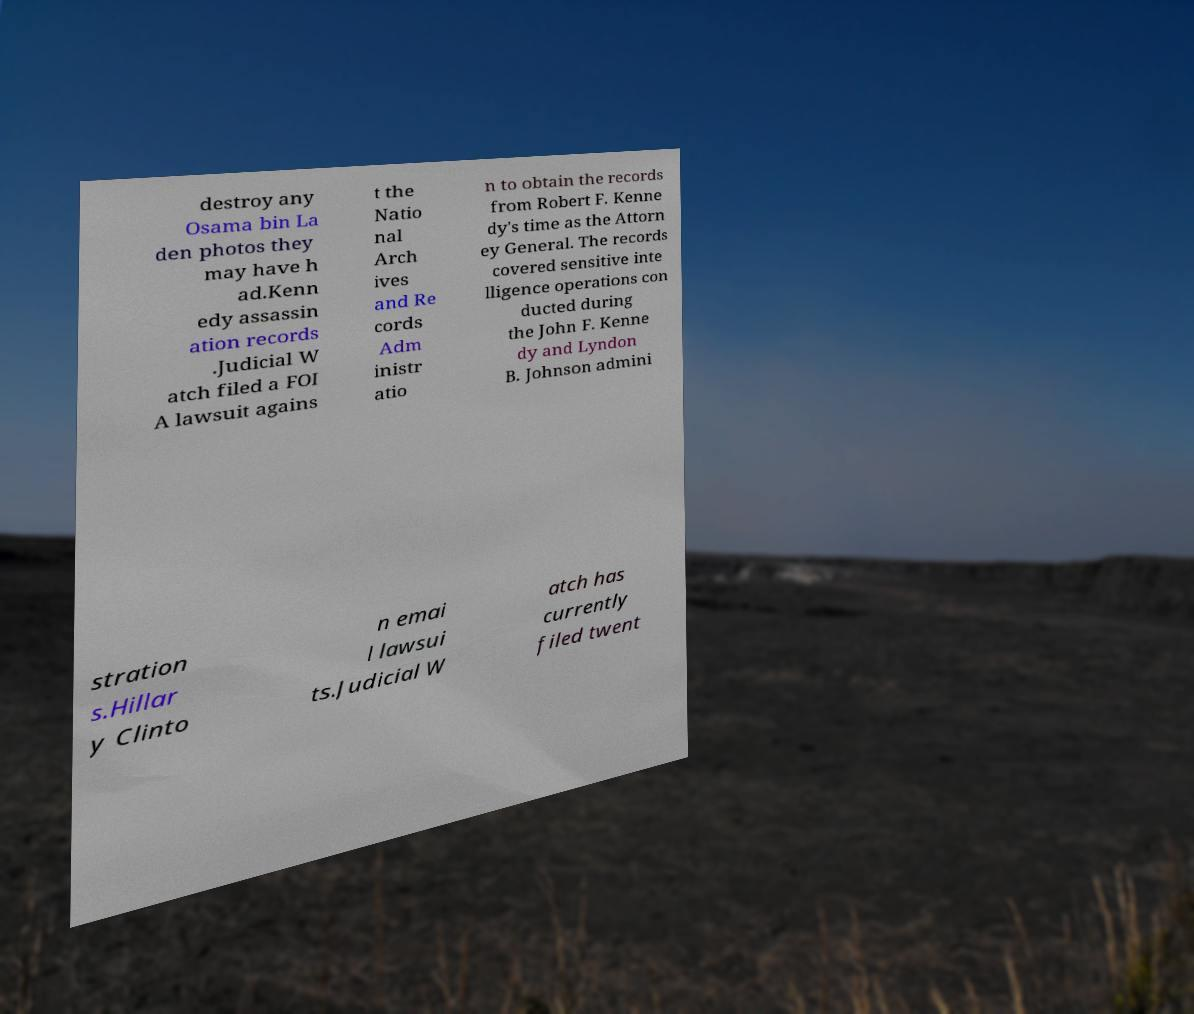Can you accurately transcribe the text from the provided image for me? destroy any Osama bin La den photos they may have h ad.Kenn edy assassin ation records .Judicial W atch filed a FOI A lawsuit agains t the Natio nal Arch ives and Re cords Adm inistr atio n to obtain the records from Robert F. Kenne dy's time as the Attorn ey General. The records covered sensitive inte lligence operations con ducted during the John F. Kenne dy and Lyndon B. Johnson admini stration s.Hillar y Clinto n emai l lawsui ts.Judicial W atch has currently filed twent 